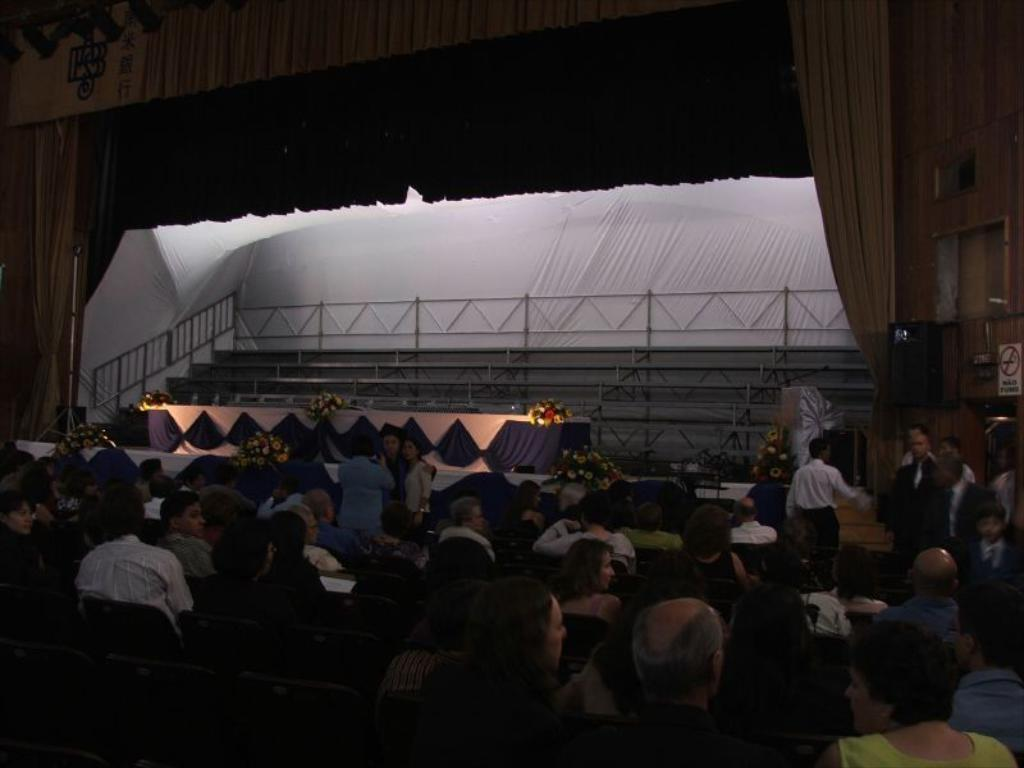What is happening in the image with the many people sitting in chairs? There are many people sitting in chairs, which suggests they might be attending an event or gathering. What is located at the front of the image? There is a dais in the front of the image, which is often used as a stage or platform for speakers or performers. What decorative elements can be seen on the dais? There are flowers on the dais, which adds to the visual appeal and possibly indicates a special occasion. What can be seen in the background of the image? There is a curtain in the background of the image, which could be used to conceal or reveal the stage area. What advice is being given to the newborn baby in the image? There is no newborn baby or advice being given in the image; it features many people sitting in chairs with a dais and flowers in the front, and a curtain in the background. 